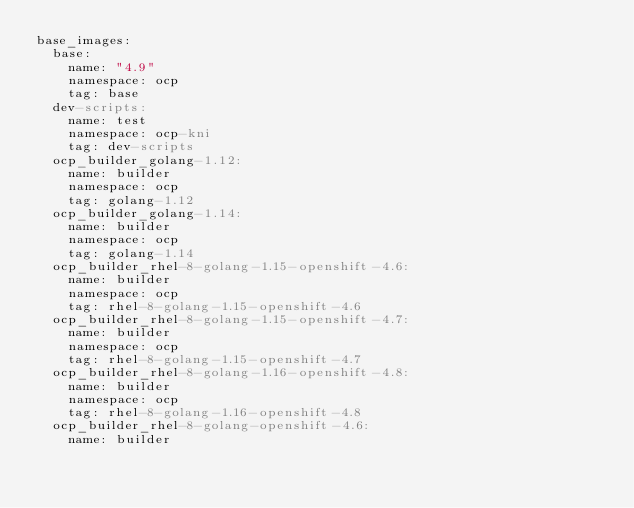Convert code to text. <code><loc_0><loc_0><loc_500><loc_500><_YAML_>base_images:
  base:
    name: "4.9"
    namespace: ocp
    tag: base
  dev-scripts:
    name: test
    namespace: ocp-kni
    tag: dev-scripts
  ocp_builder_golang-1.12:
    name: builder
    namespace: ocp
    tag: golang-1.12
  ocp_builder_golang-1.14:
    name: builder
    namespace: ocp
    tag: golang-1.14
  ocp_builder_rhel-8-golang-1.15-openshift-4.6:
    name: builder
    namespace: ocp
    tag: rhel-8-golang-1.15-openshift-4.6
  ocp_builder_rhel-8-golang-1.15-openshift-4.7:
    name: builder
    namespace: ocp
    tag: rhel-8-golang-1.15-openshift-4.7
  ocp_builder_rhel-8-golang-1.16-openshift-4.8:
    name: builder
    namespace: ocp
    tag: rhel-8-golang-1.16-openshift-4.8
  ocp_builder_rhel-8-golang-openshift-4.6:
    name: builder</code> 